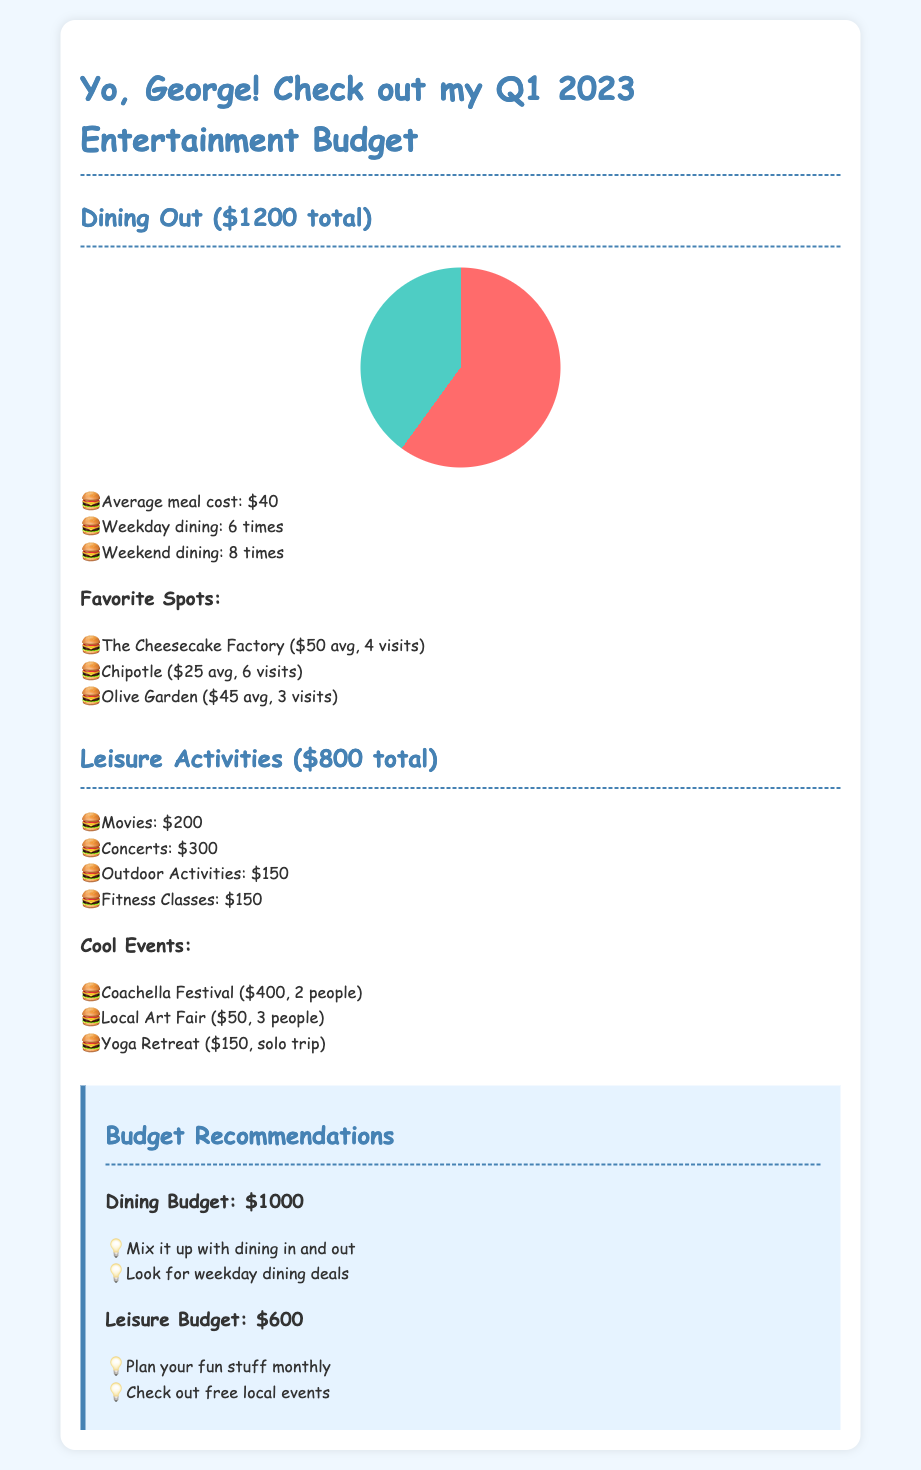What is the total dining out expense? The total dining out expense is stated directly in the document under Dining Out, which is $1200.
Answer: $1200 How many times did dining occur on weekends? The document specifies the number of weekend dining occurrences, which is 8 times.
Answer: 8 times What is the average meal cost? The average meal cost is clearly mentioned in the details, which is $40.
Answer: $40 What was the total spent on concerts? The total spent on concerts is listed as $300 in the leisure activities section.
Answer: $300 Which restaurant had the highest average meal cost? The restaurant with the highest average meal cost is The Cheesecake Factory, with an average of $50.
Answer: The Cheesecake Factory What is the budget recommendation for leisure activities? The budget recommendation for leisure activities is given in the recommendations section, which is $600.
Answer: $600 How many people attended the Coachella Festival? The document states that 2 people attended the Coachella Festival.
Answer: 2 people What is one recommendation for dining? The recommendations section suggests looking for weekday dining deals as a way to enhance the dining experience.
Answer: Look for weekday dining deals What was the total spent on fitness classes? The total spent on fitness classes is shown as $150 in leisure activities.
Answer: $150 